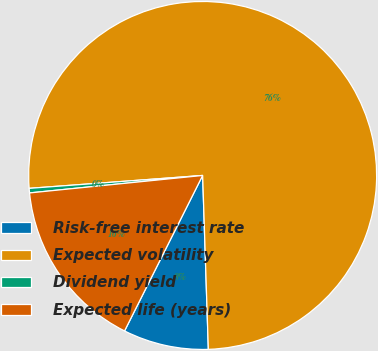<chart> <loc_0><loc_0><loc_500><loc_500><pie_chart><fcel>Risk-free interest rate<fcel>Expected volatility<fcel>Dividend yield<fcel>Expected life (years)<nl><fcel>7.93%<fcel>75.66%<fcel>0.42%<fcel>15.99%<nl></chart> 